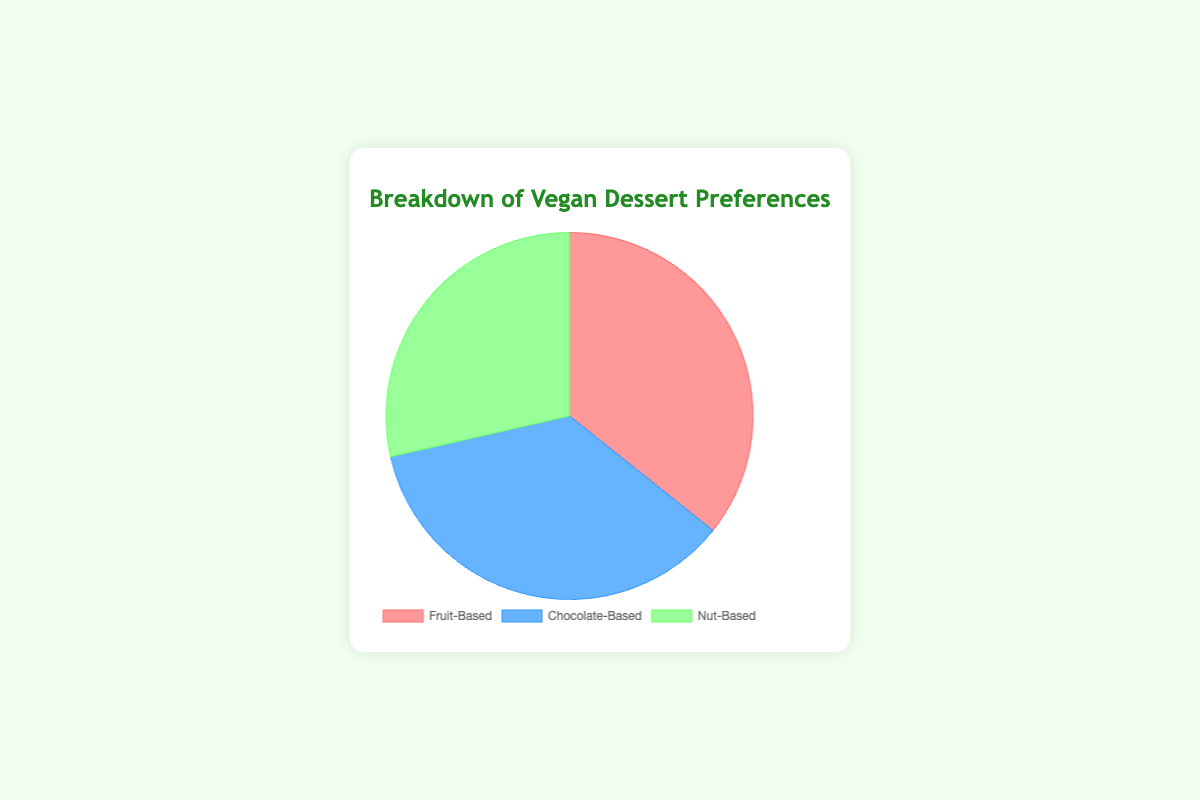Which category has the highest percentage in the breakdown of vegan dessert preferences? The chart shows that Fruit-Based and Chocolate-Based categories both have the highest percentage at 50%.
Answer: Fruit-Based and Chocolate-Based Which category has the smallest percentage in the breakdown of vegan dessert preferences? The chart shows that Nut-Based category has the smallest percentage at 40%.
Answer: Nut-Based What is the total percentage of dessert preferences covered by chocolate-based desserts? Summing up the percentages of all chocolate-based desserts from the given data points: 10% (Dark Chocolate Mousse) + 15% (Chocolate Avocado Pudding) + 20% (Vegan Brownies) + 5% (Chocolate Chip Cookies) = 50%.
Answer: 50% Which individual vegan dessert has the highest preference percentage within all categories? From the data points, Berry Sorbet (Fruit-Based) and Vegan Brownies (Chocolate-Based) both have the highest individual preference percentage at 20%.
Answer: Berry Sorbet and Vegan Brownies What is the combined preference percentage of all nut-based desserts? Summing up the percentages of all nut-based desserts from the given data points: 10% (Almond Butter Cookies) + 15% (Cashew Cheesecake) + 5% (Pecan Pie) + 10% (Walnut Brownies) = 40%.
Answer: 40% How does the preference percentage of chocolate-based desserts compare to fruit-based desserts? The chart shows both Chocolate-Based and Fruit-Based categories have the same percentage of 50%.
Answer: They are equal Which vegan dessert has the lowest preference percentage? From the data points, both Peach Cobbler (Fruit-Based) and Chocolate Chip Cookies (Chocolate-Based) have the lowest individual preference percentage at 5%.
Answer: Peach Cobbler and Chocolate Chip Cookies What are the visual attributes of the sectors representing the Chocolate-Based category? The Chocolate-Based category sector is represented in blue color and occupies 50% of the pie chart.
Answer: Blue, 50% If you sum up the percentages of the top two favorite vegan desserts, what do you get? From the data points, the top two favorite vegan desserts are Berry Sorbet (20%) and Vegan Brownies (20%). Summing these up: 20% + 20% = 40%.
Answer: 40% Is there a category that has no individual item with greater than 20% preference? From the data points, Nut-Based category items (Almond Butter Cookies - 10%, Cashew Cheesecake - 15%, Pecan Pie - 5%, Walnut Brownies - 10%) all have percentages less than or equal to 15%.
Answer: Nut-Based 